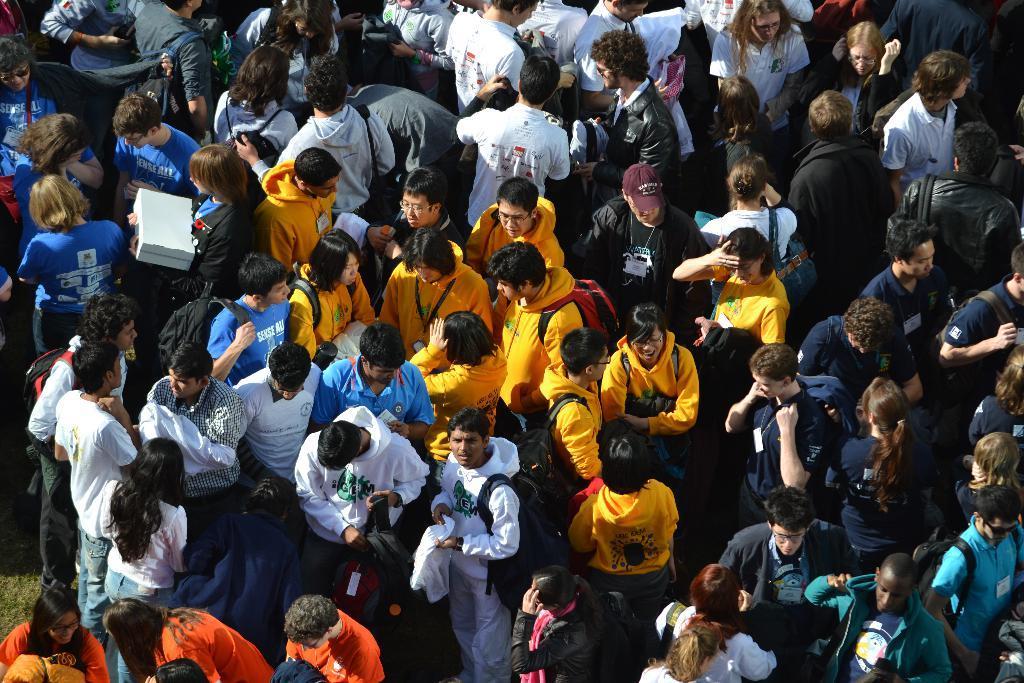Can you describe this image briefly? In the foreground of this image, there are people standing, few are wearing bags and a person is holding a box on the left. 